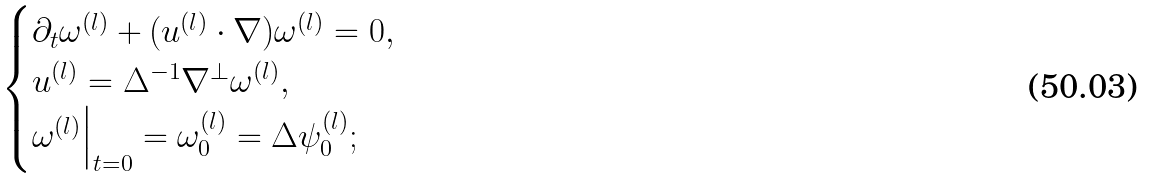<formula> <loc_0><loc_0><loc_500><loc_500>\begin{cases} \partial _ { t } \omega ^ { ( l ) } + ( u ^ { ( l ) } \cdot \nabla ) \omega ^ { ( l ) } = 0 , \\ u ^ { ( l ) } = \Delta ^ { - 1 } \nabla ^ { \perp } \omega ^ { ( l ) } , \\ \omega ^ { ( l ) } \Big | _ { t = 0 } = \omega _ { 0 } ^ { ( l ) } = \Delta \psi _ { 0 } ^ { ( l ) } ; \end{cases}</formula> 